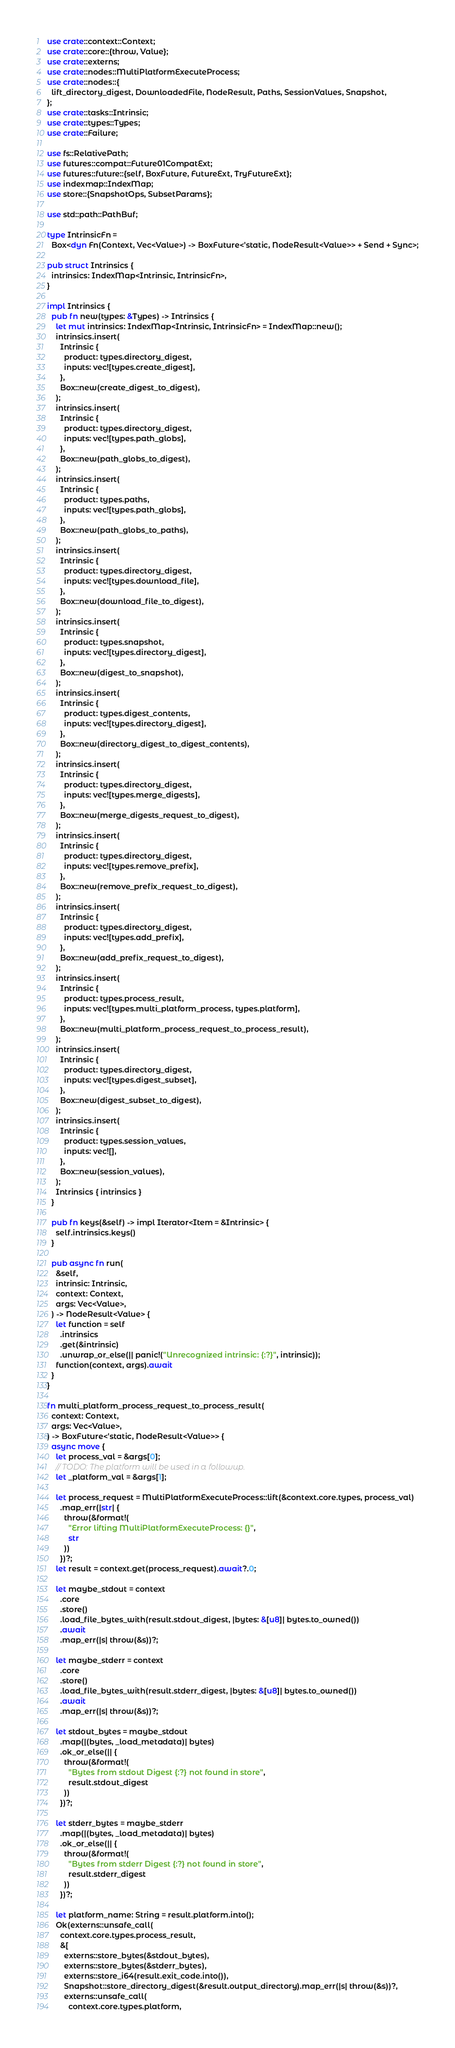Convert code to text. <code><loc_0><loc_0><loc_500><loc_500><_Rust_>use crate::context::Context;
use crate::core::{throw, Value};
use crate::externs;
use crate::nodes::MultiPlatformExecuteProcess;
use crate::nodes::{
  lift_directory_digest, DownloadedFile, NodeResult, Paths, SessionValues, Snapshot,
};
use crate::tasks::Intrinsic;
use crate::types::Types;
use crate::Failure;

use fs::RelativePath;
use futures::compat::Future01CompatExt;
use futures::future::{self, BoxFuture, FutureExt, TryFutureExt};
use indexmap::IndexMap;
use store::{SnapshotOps, SubsetParams};

use std::path::PathBuf;

type IntrinsicFn =
  Box<dyn Fn(Context, Vec<Value>) -> BoxFuture<'static, NodeResult<Value>> + Send + Sync>;

pub struct Intrinsics {
  intrinsics: IndexMap<Intrinsic, IntrinsicFn>,
}

impl Intrinsics {
  pub fn new(types: &Types) -> Intrinsics {
    let mut intrinsics: IndexMap<Intrinsic, IntrinsicFn> = IndexMap::new();
    intrinsics.insert(
      Intrinsic {
        product: types.directory_digest,
        inputs: vec![types.create_digest],
      },
      Box::new(create_digest_to_digest),
    );
    intrinsics.insert(
      Intrinsic {
        product: types.directory_digest,
        inputs: vec![types.path_globs],
      },
      Box::new(path_globs_to_digest),
    );
    intrinsics.insert(
      Intrinsic {
        product: types.paths,
        inputs: vec![types.path_globs],
      },
      Box::new(path_globs_to_paths),
    );
    intrinsics.insert(
      Intrinsic {
        product: types.directory_digest,
        inputs: vec![types.download_file],
      },
      Box::new(download_file_to_digest),
    );
    intrinsics.insert(
      Intrinsic {
        product: types.snapshot,
        inputs: vec![types.directory_digest],
      },
      Box::new(digest_to_snapshot),
    );
    intrinsics.insert(
      Intrinsic {
        product: types.digest_contents,
        inputs: vec![types.directory_digest],
      },
      Box::new(directory_digest_to_digest_contents),
    );
    intrinsics.insert(
      Intrinsic {
        product: types.directory_digest,
        inputs: vec![types.merge_digests],
      },
      Box::new(merge_digests_request_to_digest),
    );
    intrinsics.insert(
      Intrinsic {
        product: types.directory_digest,
        inputs: vec![types.remove_prefix],
      },
      Box::new(remove_prefix_request_to_digest),
    );
    intrinsics.insert(
      Intrinsic {
        product: types.directory_digest,
        inputs: vec![types.add_prefix],
      },
      Box::new(add_prefix_request_to_digest),
    );
    intrinsics.insert(
      Intrinsic {
        product: types.process_result,
        inputs: vec![types.multi_platform_process, types.platform],
      },
      Box::new(multi_platform_process_request_to_process_result),
    );
    intrinsics.insert(
      Intrinsic {
        product: types.directory_digest,
        inputs: vec![types.digest_subset],
      },
      Box::new(digest_subset_to_digest),
    );
    intrinsics.insert(
      Intrinsic {
        product: types.session_values,
        inputs: vec![],
      },
      Box::new(session_values),
    );
    Intrinsics { intrinsics }
  }

  pub fn keys(&self) -> impl Iterator<Item = &Intrinsic> {
    self.intrinsics.keys()
  }

  pub async fn run(
    &self,
    intrinsic: Intrinsic,
    context: Context,
    args: Vec<Value>,
  ) -> NodeResult<Value> {
    let function = self
      .intrinsics
      .get(&intrinsic)
      .unwrap_or_else(|| panic!("Unrecognized intrinsic: {:?}", intrinsic));
    function(context, args).await
  }
}

fn multi_platform_process_request_to_process_result(
  context: Context,
  args: Vec<Value>,
) -> BoxFuture<'static, NodeResult<Value>> {
  async move {
    let process_val = &args[0];
    // TODO: The platform will be used in a followup.
    let _platform_val = &args[1];

    let process_request = MultiPlatformExecuteProcess::lift(&context.core.types, process_val)
      .map_err(|str| {
        throw(&format!(
          "Error lifting MultiPlatformExecuteProcess: {}",
          str
        ))
      })?;
    let result = context.get(process_request).await?.0;

    let maybe_stdout = context
      .core
      .store()
      .load_file_bytes_with(result.stdout_digest, |bytes: &[u8]| bytes.to_owned())
      .await
      .map_err(|s| throw(&s))?;

    let maybe_stderr = context
      .core
      .store()
      .load_file_bytes_with(result.stderr_digest, |bytes: &[u8]| bytes.to_owned())
      .await
      .map_err(|s| throw(&s))?;

    let stdout_bytes = maybe_stdout
      .map(|(bytes, _load_metadata)| bytes)
      .ok_or_else(|| {
        throw(&format!(
          "Bytes from stdout Digest {:?} not found in store",
          result.stdout_digest
        ))
      })?;

    let stderr_bytes = maybe_stderr
      .map(|(bytes, _load_metadata)| bytes)
      .ok_or_else(|| {
        throw(&format!(
          "Bytes from stderr Digest {:?} not found in store",
          result.stderr_digest
        ))
      })?;

    let platform_name: String = result.platform.into();
    Ok(externs::unsafe_call(
      context.core.types.process_result,
      &[
        externs::store_bytes(&stdout_bytes),
        externs::store_bytes(&stderr_bytes),
        externs::store_i64(result.exit_code.into()),
        Snapshot::store_directory_digest(&result.output_directory).map_err(|s| throw(&s))?,
        externs::unsafe_call(
          context.core.types.platform,</code> 